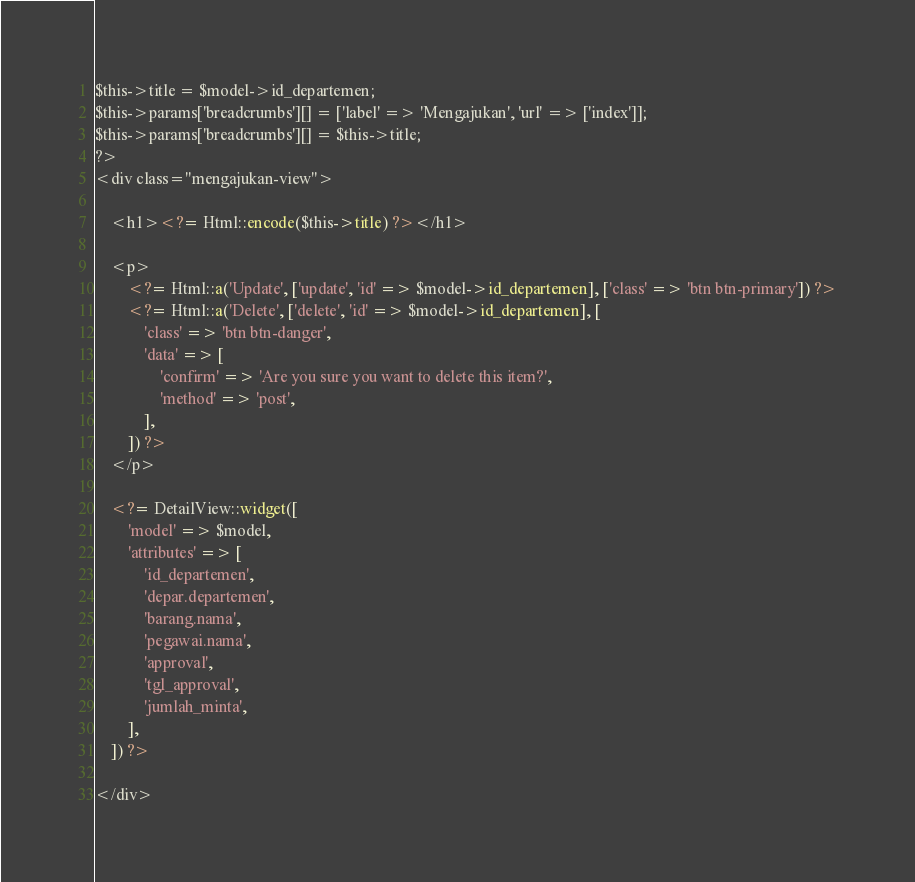<code> <loc_0><loc_0><loc_500><loc_500><_PHP_>$this->title = $model->id_departemen;
$this->params['breadcrumbs'][] = ['label' => 'Mengajukan', 'url' => ['index']];
$this->params['breadcrumbs'][] = $this->title;
?>
<div class="mengajukan-view">

    <h1><?= Html::encode($this->title) ?></h1>

    <p>
        <?= Html::a('Update', ['update', 'id' => $model->id_departemen], ['class' => 'btn btn-primary']) ?>
        <?= Html::a('Delete', ['delete', 'id' => $model->id_departemen], [
            'class' => 'btn btn-danger',
            'data' => [
                'confirm' => 'Are you sure you want to delete this item?',
                'method' => 'post',
            ],
        ]) ?>
    </p>

    <?= DetailView::widget([
        'model' => $model,
        'attributes' => [
            'id_departemen',
            'depar.departemen',
            'barang.nama',
            'pegawai.nama',
            'approval',
            'tgl_approval',
            'jumlah_minta',
        ],
    ]) ?>

</div>
</code> 